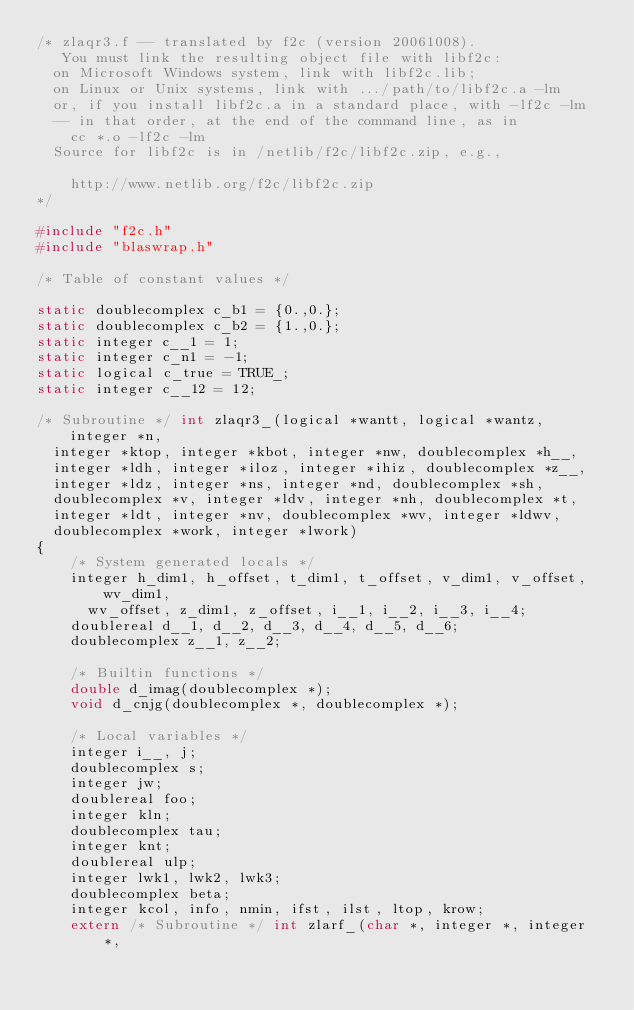<code> <loc_0><loc_0><loc_500><loc_500><_C_>/* zlaqr3.f -- translated by f2c (version 20061008).
   You must link the resulting object file with libf2c:
	on Microsoft Windows system, link with libf2c.lib;
	on Linux or Unix systems, link with .../path/to/libf2c.a -lm
	or, if you install libf2c.a in a standard place, with -lf2c -lm
	-- in that order, at the end of the command line, as in
		cc *.o -lf2c -lm
	Source for libf2c is in /netlib/f2c/libf2c.zip, e.g.,

		http://www.netlib.org/f2c/libf2c.zip
*/

#include "f2c.h"
#include "blaswrap.h"

/* Table of constant values */

static doublecomplex c_b1 = {0.,0.};
static doublecomplex c_b2 = {1.,0.};
static integer c__1 = 1;
static integer c_n1 = -1;
static logical c_true = TRUE_;
static integer c__12 = 12;

/* Subroutine */ int zlaqr3_(logical *wantt, logical *wantz, integer *n, 
	integer *ktop, integer *kbot, integer *nw, doublecomplex *h__, 
	integer *ldh, integer *iloz, integer *ihiz, doublecomplex *z__, 
	integer *ldz, integer *ns, integer *nd, doublecomplex *sh, 
	doublecomplex *v, integer *ldv, integer *nh, doublecomplex *t, 
	integer *ldt, integer *nv, doublecomplex *wv, integer *ldwv, 
	doublecomplex *work, integer *lwork)
{
    /* System generated locals */
    integer h_dim1, h_offset, t_dim1, t_offset, v_dim1, v_offset, wv_dim1, 
	    wv_offset, z_dim1, z_offset, i__1, i__2, i__3, i__4;
    doublereal d__1, d__2, d__3, d__4, d__5, d__6;
    doublecomplex z__1, z__2;

    /* Builtin functions */
    double d_imag(doublecomplex *);
    void d_cnjg(doublecomplex *, doublecomplex *);

    /* Local variables */
    integer i__, j;
    doublecomplex s;
    integer jw;
    doublereal foo;
    integer kln;
    doublecomplex tau;
    integer knt;
    doublereal ulp;
    integer lwk1, lwk2, lwk3;
    doublecomplex beta;
    integer kcol, info, nmin, ifst, ilst, ltop, krow;
    extern /* Subroutine */ int zlarf_(char *, integer *, integer *, </code> 